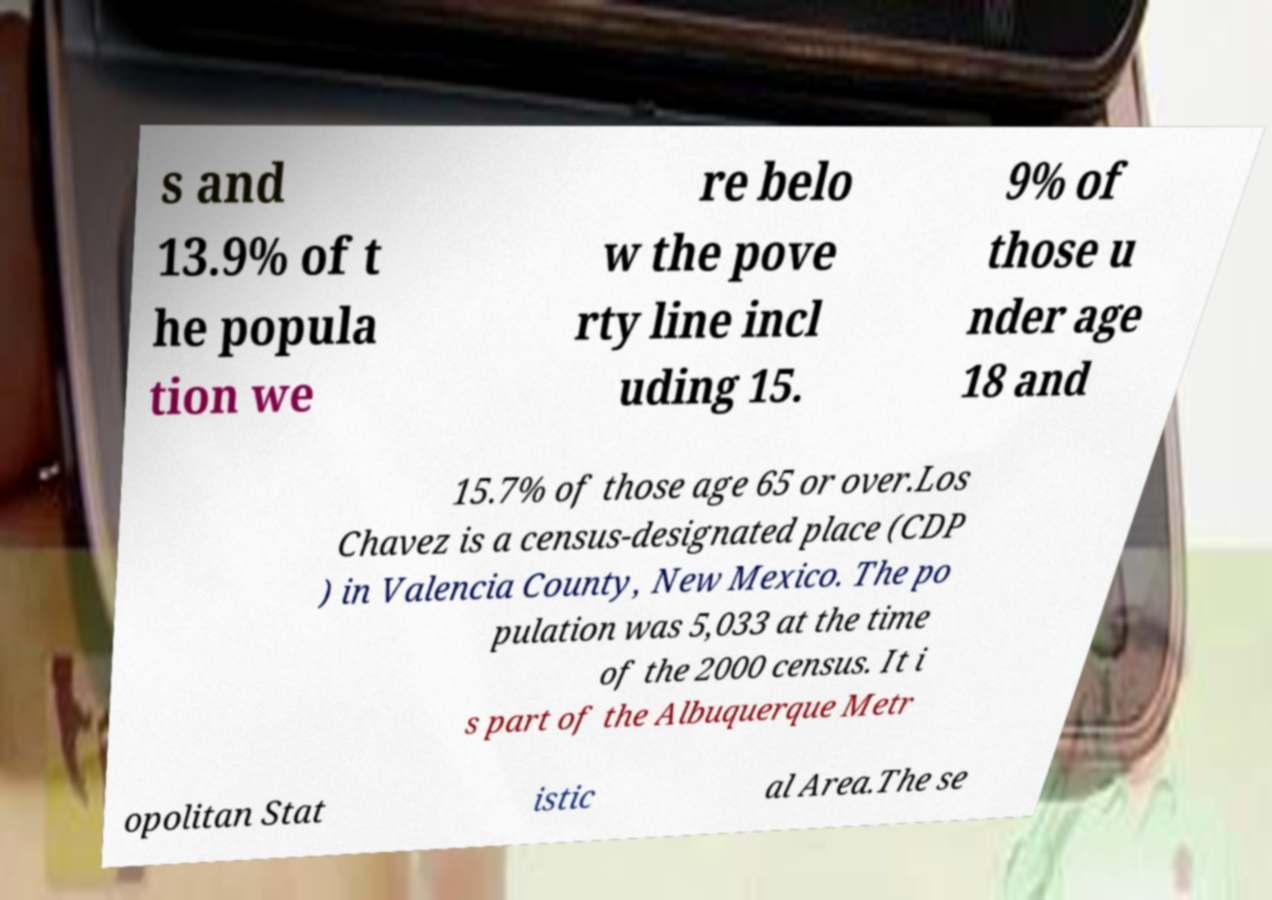There's text embedded in this image that I need extracted. Can you transcribe it verbatim? s and 13.9% of t he popula tion we re belo w the pove rty line incl uding 15. 9% of those u nder age 18 and 15.7% of those age 65 or over.Los Chavez is a census-designated place (CDP ) in Valencia County, New Mexico. The po pulation was 5,033 at the time of the 2000 census. It i s part of the Albuquerque Metr opolitan Stat istic al Area.The se 